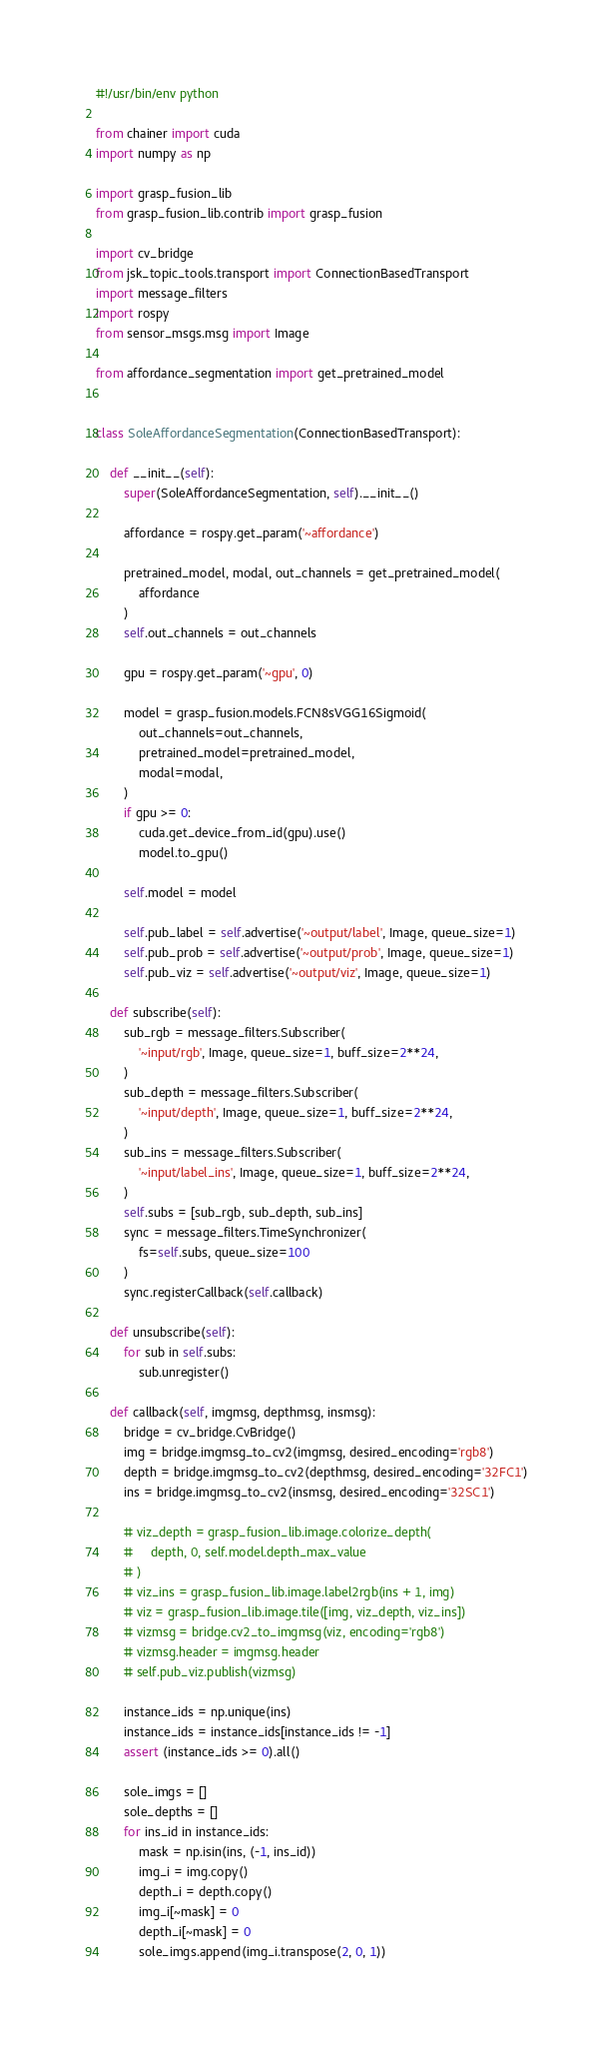<code> <loc_0><loc_0><loc_500><loc_500><_Python_>#!/usr/bin/env python

from chainer import cuda
import numpy as np

import grasp_fusion_lib
from grasp_fusion_lib.contrib import grasp_fusion

import cv_bridge
from jsk_topic_tools.transport import ConnectionBasedTransport
import message_filters
import rospy
from sensor_msgs.msg import Image

from affordance_segmentation import get_pretrained_model


class SoleAffordanceSegmentation(ConnectionBasedTransport):

    def __init__(self):
        super(SoleAffordanceSegmentation, self).__init__()

        affordance = rospy.get_param('~affordance')

        pretrained_model, modal, out_channels = get_pretrained_model(
            affordance
        )
        self.out_channels = out_channels

        gpu = rospy.get_param('~gpu', 0)

        model = grasp_fusion.models.FCN8sVGG16Sigmoid(
            out_channels=out_channels,
            pretrained_model=pretrained_model,
            modal=modal,
        )
        if gpu >= 0:
            cuda.get_device_from_id(gpu).use()
            model.to_gpu()

        self.model = model

        self.pub_label = self.advertise('~output/label', Image, queue_size=1)
        self.pub_prob = self.advertise('~output/prob', Image, queue_size=1)
        self.pub_viz = self.advertise('~output/viz', Image, queue_size=1)

    def subscribe(self):
        sub_rgb = message_filters.Subscriber(
            '~input/rgb', Image, queue_size=1, buff_size=2**24,
        )
        sub_depth = message_filters.Subscriber(
            '~input/depth', Image, queue_size=1, buff_size=2**24,
        )
        sub_ins = message_filters.Subscriber(
            '~input/label_ins', Image, queue_size=1, buff_size=2**24,
        )
        self.subs = [sub_rgb, sub_depth, sub_ins]
        sync = message_filters.TimeSynchronizer(
            fs=self.subs, queue_size=100
        )
        sync.registerCallback(self.callback)

    def unsubscribe(self):
        for sub in self.subs:
            sub.unregister()

    def callback(self, imgmsg, depthmsg, insmsg):
        bridge = cv_bridge.CvBridge()
        img = bridge.imgmsg_to_cv2(imgmsg, desired_encoding='rgb8')
        depth = bridge.imgmsg_to_cv2(depthmsg, desired_encoding='32FC1')
        ins = bridge.imgmsg_to_cv2(insmsg, desired_encoding='32SC1')

        # viz_depth = grasp_fusion_lib.image.colorize_depth(
        #     depth, 0, self.model.depth_max_value
        # )
        # viz_ins = grasp_fusion_lib.image.label2rgb(ins + 1, img)
        # viz = grasp_fusion_lib.image.tile([img, viz_depth, viz_ins])
        # vizmsg = bridge.cv2_to_imgmsg(viz, encoding='rgb8')
        # vizmsg.header = imgmsg.header
        # self.pub_viz.publish(vizmsg)

        instance_ids = np.unique(ins)
        instance_ids = instance_ids[instance_ids != -1]
        assert (instance_ids >= 0).all()

        sole_imgs = []
        sole_depths = []
        for ins_id in instance_ids:
            mask = np.isin(ins, (-1, ins_id))
            img_i = img.copy()
            depth_i = depth.copy()
            img_i[~mask] = 0
            depth_i[~mask] = 0
            sole_imgs.append(img_i.transpose(2, 0, 1))</code> 